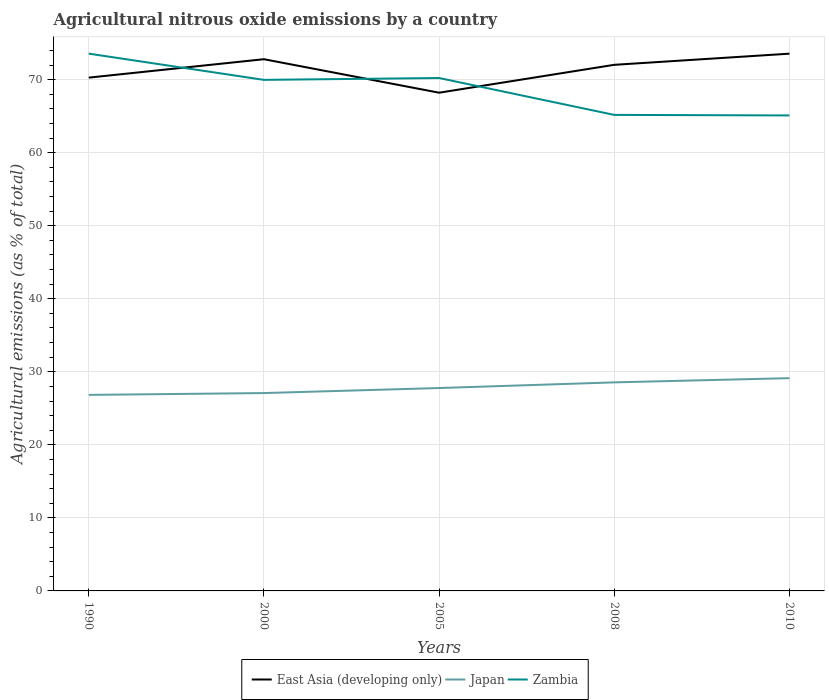Does the line corresponding to East Asia (developing only) intersect with the line corresponding to Zambia?
Keep it short and to the point. Yes. Across all years, what is the maximum amount of agricultural nitrous oxide emitted in East Asia (developing only)?
Provide a succinct answer. 68.21. What is the total amount of agricultural nitrous oxide emitted in Japan in the graph?
Provide a short and direct response. -0.77. What is the difference between the highest and the second highest amount of agricultural nitrous oxide emitted in Zambia?
Offer a very short reply. 8.46. What is the difference between the highest and the lowest amount of agricultural nitrous oxide emitted in Zambia?
Offer a terse response. 3. Is the amount of agricultural nitrous oxide emitted in East Asia (developing only) strictly greater than the amount of agricultural nitrous oxide emitted in Japan over the years?
Give a very brief answer. No. How many lines are there?
Make the answer very short. 3. How many years are there in the graph?
Your answer should be very brief. 5. Are the values on the major ticks of Y-axis written in scientific E-notation?
Make the answer very short. No. Where does the legend appear in the graph?
Your response must be concise. Bottom center. How many legend labels are there?
Provide a short and direct response. 3. What is the title of the graph?
Provide a succinct answer. Agricultural nitrous oxide emissions by a country. What is the label or title of the X-axis?
Offer a very short reply. Years. What is the label or title of the Y-axis?
Give a very brief answer. Agricultural emissions (as % of total). What is the Agricultural emissions (as % of total) of East Asia (developing only) in 1990?
Your answer should be compact. 70.28. What is the Agricultural emissions (as % of total) of Japan in 1990?
Offer a very short reply. 26.84. What is the Agricultural emissions (as % of total) in Zambia in 1990?
Provide a succinct answer. 73.56. What is the Agricultural emissions (as % of total) of East Asia (developing only) in 2000?
Your answer should be very brief. 72.8. What is the Agricultural emissions (as % of total) of Japan in 2000?
Ensure brevity in your answer.  27.09. What is the Agricultural emissions (as % of total) in Zambia in 2000?
Make the answer very short. 69.97. What is the Agricultural emissions (as % of total) in East Asia (developing only) in 2005?
Keep it short and to the point. 68.21. What is the Agricultural emissions (as % of total) of Japan in 2005?
Make the answer very short. 27.78. What is the Agricultural emissions (as % of total) of Zambia in 2005?
Your answer should be very brief. 70.22. What is the Agricultural emissions (as % of total) in East Asia (developing only) in 2008?
Your answer should be compact. 72.03. What is the Agricultural emissions (as % of total) in Japan in 2008?
Provide a succinct answer. 28.55. What is the Agricultural emissions (as % of total) of Zambia in 2008?
Offer a terse response. 65.17. What is the Agricultural emissions (as % of total) in East Asia (developing only) in 2010?
Make the answer very short. 73.56. What is the Agricultural emissions (as % of total) of Japan in 2010?
Give a very brief answer. 29.13. What is the Agricultural emissions (as % of total) of Zambia in 2010?
Your response must be concise. 65.1. Across all years, what is the maximum Agricultural emissions (as % of total) in East Asia (developing only)?
Provide a short and direct response. 73.56. Across all years, what is the maximum Agricultural emissions (as % of total) in Japan?
Provide a succinct answer. 29.13. Across all years, what is the maximum Agricultural emissions (as % of total) of Zambia?
Ensure brevity in your answer.  73.56. Across all years, what is the minimum Agricultural emissions (as % of total) in East Asia (developing only)?
Your answer should be compact. 68.21. Across all years, what is the minimum Agricultural emissions (as % of total) in Japan?
Your answer should be compact. 26.84. Across all years, what is the minimum Agricultural emissions (as % of total) of Zambia?
Provide a short and direct response. 65.1. What is the total Agricultural emissions (as % of total) of East Asia (developing only) in the graph?
Give a very brief answer. 356.87. What is the total Agricultural emissions (as % of total) in Japan in the graph?
Provide a short and direct response. 139.39. What is the total Agricultural emissions (as % of total) of Zambia in the graph?
Keep it short and to the point. 344.03. What is the difference between the Agricultural emissions (as % of total) in East Asia (developing only) in 1990 and that in 2000?
Offer a terse response. -2.52. What is the difference between the Agricultural emissions (as % of total) in Japan in 1990 and that in 2000?
Make the answer very short. -0.25. What is the difference between the Agricultural emissions (as % of total) of Zambia in 1990 and that in 2000?
Give a very brief answer. 3.59. What is the difference between the Agricultural emissions (as % of total) in East Asia (developing only) in 1990 and that in 2005?
Provide a succinct answer. 2.07. What is the difference between the Agricultural emissions (as % of total) in Japan in 1990 and that in 2005?
Give a very brief answer. -0.94. What is the difference between the Agricultural emissions (as % of total) of Zambia in 1990 and that in 2005?
Give a very brief answer. 3.34. What is the difference between the Agricultural emissions (as % of total) in East Asia (developing only) in 1990 and that in 2008?
Your answer should be very brief. -1.75. What is the difference between the Agricultural emissions (as % of total) of Japan in 1990 and that in 2008?
Your answer should be very brief. -1.71. What is the difference between the Agricultural emissions (as % of total) of Zambia in 1990 and that in 2008?
Offer a very short reply. 8.39. What is the difference between the Agricultural emissions (as % of total) in East Asia (developing only) in 1990 and that in 2010?
Provide a succinct answer. -3.28. What is the difference between the Agricultural emissions (as % of total) of Japan in 1990 and that in 2010?
Provide a short and direct response. -2.29. What is the difference between the Agricultural emissions (as % of total) of Zambia in 1990 and that in 2010?
Give a very brief answer. 8.46. What is the difference between the Agricultural emissions (as % of total) of East Asia (developing only) in 2000 and that in 2005?
Provide a short and direct response. 4.59. What is the difference between the Agricultural emissions (as % of total) of Japan in 2000 and that in 2005?
Your answer should be very brief. -0.69. What is the difference between the Agricultural emissions (as % of total) in Zambia in 2000 and that in 2005?
Offer a very short reply. -0.25. What is the difference between the Agricultural emissions (as % of total) in East Asia (developing only) in 2000 and that in 2008?
Your answer should be compact. 0.77. What is the difference between the Agricultural emissions (as % of total) of Japan in 2000 and that in 2008?
Your answer should be very brief. -1.46. What is the difference between the Agricultural emissions (as % of total) in Zambia in 2000 and that in 2008?
Your answer should be compact. 4.8. What is the difference between the Agricultural emissions (as % of total) of East Asia (developing only) in 2000 and that in 2010?
Your answer should be very brief. -0.76. What is the difference between the Agricultural emissions (as % of total) in Japan in 2000 and that in 2010?
Provide a short and direct response. -2.04. What is the difference between the Agricultural emissions (as % of total) in Zambia in 2000 and that in 2010?
Your answer should be very brief. 4.87. What is the difference between the Agricultural emissions (as % of total) in East Asia (developing only) in 2005 and that in 2008?
Your response must be concise. -3.82. What is the difference between the Agricultural emissions (as % of total) of Japan in 2005 and that in 2008?
Give a very brief answer. -0.77. What is the difference between the Agricultural emissions (as % of total) of Zambia in 2005 and that in 2008?
Keep it short and to the point. 5.05. What is the difference between the Agricultural emissions (as % of total) in East Asia (developing only) in 2005 and that in 2010?
Your answer should be compact. -5.34. What is the difference between the Agricultural emissions (as % of total) of Japan in 2005 and that in 2010?
Your answer should be very brief. -1.35. What is the difference between the Agricultural emissions (as % of total) of Zambia in 2005 and that in 2010?
Make the answer very short. 5.12. What is the difference between the Agricultural emissions (as % of total) in East Asia (developing only) in 2008 and that in 2010?
Your response must be concise. -1.53. What is the difference between the Agricultural emissions (as % of total) in Japan in 2008 and that in 2010?
Ensure brevity in your answer.  -0.58. What is the difference between the Agricultural emissions (as % of total) of Zambia in 2008 and that in 2010?
Ensure brevity in your answer.  0.07. What is the difference between the Agricultural emissions (as % of total) in East Asia (developing only) in 1990 and the Agricultural emissions (as % of total) in Japan in 2000?
Offer a terse response. 43.19. What is the difference between the Agricultural emissions (as % of total) in East Asia (developing only) in 1990 and the Agricultural emissions (as % of total) in Zambia in 2000?
Provide a succinct answer. 0.31. What is the difference between the Agricultural emissions (as % of total) in Japan in 1990 and the Agricultural emissions (as % of total) in Zambia in 2000?
Offer a terse response. -43.13. What is the difference between the Agricultural emissions (as % of total) in East Asia (developing only) in 1990 and the Agricultural emissions (as % of total) in Japan in 2005?
Keep it short and to the point. 42.5. What is the difference between the Agricultural emissions (as % of total) in East Asia (developing only) in 1990 and the Agricultural emissions (as % of total) in Zambia in 2005?
Your answer should be very brief. 0.05. What is the difference between the Agricultural emissions (as % of total) of Japan in 1990 and the Agricultural emissions (as % of total) of Zambia in 2005?
Offer a terse response. -43.38. What is the difference between the Agricultural emissions (as % of total) in East Asia (developing only) in 1990 and the Agricultural emissions (as % of total) in Japan in 2008?
Offer a very short reply. 41.73. What is the difference between the Agricultural emissions (as % of total) in East Asia (developing only) in 1990 and the Agricultural emissions (as % of total) in Zambia in 2008?
Offer a terse response. 5.1. What is the difference between the Agricultural emissions (as % of total) of Japan in 1990 and the Agricultural emissions (as % of total) of Zambia in 2008?
Offer a very short reply. -38.34. What is the difference between the Agricultural emissions (as % of total) of East Asia (developing only) in 1990 and the Agricultural emissions (as % of total) of Japan in 2010?
Provide a short and direct response. 41.15. What is the difference between the Agricultural emissions (as % of total) in East Asia (developing only) in 1990 and the Agricultural emissions (as % of total) in Zambia in 2010?
Keep it short and to the point. 5.18. What is the difference between the Agricultural emissions (as % of total) in Japan in 1990 and the Agricultural emissions (as % of total) in Zambia in 2010?
Ensure brevity in your answer.  -38.26. What is the difference between the Agricultural emissions (as % of total) in East Asia (developing only) in 2000 and the Agricultural emissions (as % of total) in Japan in 2005?
Provide a short and direct response. 45.02. What is the difference between the Agricultural emissions (as % of total) of East Asia (developing only) in 2000 and the Agricultural emissions (as % of total) of Zambia in 2005?
Your response must be concise. 2.58. What is the difference between the Agricultural emissions (as % of total) in Japan in 2000 and the Agricultural emissions (as % of total) in Zambia in 2005?
Your answer should be very brief. -43.13. What is the difference between the Agricultural emissions (as % of total) of East Asia (developing only) in 2000 and the Agricultural emissions (as % of total) of Japan in 2008?
Provide a succinct answer. 44.25. What is the difference between the Agricultural emissions (as % of total) of East Asia (developing only) in 2000 and the Agricultural emissions (as % of total) of Zambia in 2008?
Your response must be concise. 7.62. What is the difference between the Agricultural emissions (as % of total) in Japan in 2000 and the Agricultural emissions (as % of total) in Zambia in 2008?
Your response must be concise. -38.09. What is the difference between the Agricultural emissions (as % of total) of East Asia (developing only) in 2000 and the Agricultural emissions (as % of total) of Japan in 2010?
Offer a terse response. 43.67. What is the difference between the Agricultural emissions (as % of total) of East Asia (developing only) in 2000 and the Agricultural emissions (as % of total) of Zambia in 2010?
Offer a very short reply. 7.7. What is the difference between the Agricultural emissions (as % of total) of Japan in 2000 and the Agricultural emissions (as % of total) of Zambia in 2010?
Provide a short and direct response. -38.01. What is the difference between the Agricultural emissions (as % of total) in East Asia (developing only) in 2005 and the Agricultural emissions (as % of total) in Japan in 2008?
Your answer should be very brief. 39.66. What is the difference between the Agricultural emissions (as % of total) of East Asia (developing only) in 2005 and the Agricultural emissions (as % of total) of Zambia in 2008?
Keep it short and to the point. 3.04. What is the difference between the Agricultural emissions (as % of total) in Japan in 2005 and the Agricultural emissions (as % of total) in Zambia in 2008?
Your answer should be very brief. -37.4. What is the difference between the Agricultural emissions (as % of total) in East Asia (developing only) in 2005 and the Agricultural emissions (as % of total) in Japan in 2010?
Give a very brief answer. 39.08. What is the difference between the Agricultural emissions (as % of total) of East Asia (developing only) in 2005 and the Agricultural emissions (as % of total) of Zambia in 2010?
Your response must be concise. 3.11. What is the difference between the Agricultural emissions (as % of total) in Japan in 2005 and the Agricultural emissions (as % of total) in Zambia in 2010?
Offer a very short reply. -37.32. What is the difference between the Agricultural emissions (as % of total) in East Asia (developing only) in 2008 and the Agricultural emissions (as % of total) in Japan in 2010?
Make the answer very short. 42.9. What is the difference between the Agricultural emissions (as % of total) in East Asia (developing only) in 2008 and the Agricultural emissions (as % of total) in Zambia in 2010?
Your answer should be very brief. 6.93. What is the difference between the Agricultural emissions (as % of total) in Japan in 2008 and the Agricultural emissions (as % of total) in Zambia in 2010?
Offer a terse response. -36.55. What is the average Agricultural emissions (as % of total) of East Asia (developing only) per year?
Make the answer very short. 71.37. What is the average Agricultural emissions (as % of total) in Japan per year?
Offer a terse response. 27.88. What is the average Agricultural emissions (as % of total) in Zambia per year?
Provide a succinct answer. 68.81. In the year 1990, what is the difference between the Agricultural emissions (as % of total) in East Asia (developing only) and Agricultural emissions (as % of total) in Japan?
Offer a very short reply. 43.44. In the year 1990, what is the difference between the Agricultural emissions (as % of total) of East Asia (developing only) and Agricultural emissions (as % of total) of Zambia?
Your response must be concise. -3.28. In the year 1990, what is the difference between the Agricultural emissions (as % of total) in Japan and Agricultural emissions (as % of total) in Zambia?
Provide a short and direct response. -46.72. In the year 2000, what is the difference between the Agricultural emissions (as % of total) of East Asia (developing only) and Agricultural emissions (as % of total) of Japan?
Ensure brevity in your answer.  45.71. In the year 2000, what is the difference between the Agricultural emissions (as % of total) in East Asia (developing only) and Agricultural emissions (as % of total) in Zambia?
Offer a very short reply. 2.83. In the year 2000, what is the difference between the Agricultural emissions (as % of total) of Japan and Agricultural emissions (as % of total) of Zambia?
Your answer should be compact. -42.88. In the year 2005, what is the difference between the Agricultural emissions (as % of total) of East Asia (developing only) and Agricultural emissions (as % of total) of Japan?
Provide a short and direct response. 40.43. In the year 2005, what is the difference between the Agricultural emissions (as % of total) of East Asia (developing only) and Agricultural emissions (as % of total) of Zambia?
Your answer should be very brief. -2.01. In the year 2005, what is the difference between the Agricultural emissions (as % of total) in Japan and Agricultural emissions (as % of total) in Zambia?
Provide a short and direct response. -42.44. In the year 2008, what is the difference between the Agricultural emissions (as % of total) of East Asia (developing only) and Agricultural emissions (as % of total) of Japan?
Offer a very short reply. 43.48. In the year 2008, what is the difference between the Agricultural emissions (as % of total) of East Asia (developing only) and Agricultural emissions (as % of total) of Zambia?
Your answer should be very brief. 6.86. In the year 2008, what is the difference between the Agricultural emissions (as % of total) of Japan and Agricultural emissions (as % of total) of Zambia?
Ensure brevity in your answer.  -36.62. In the year 2010, what is the difference between the Agricultural emissions (as % of total) in East Asia (developing only) and Agricultural emissions (as % of total) in Japan?
Keep it short and to the point. 44.43. In the year 2010, what is the difference between the Agricultural emissions (as % of total) in East Asia (developing only) and Agricultural emissions (as % of total) in Zambia?
Offer a terse response. 8.46. In the year 2010, what is the difference between the Agricultural emissions (as % of total) in Japan and Agricultural emissions (as % of total) in Zambia?
Provide a succinct answer. -35.97. What is the ratio of the Agricultural emissions (as % of total) in East Asia (developing only) in 1990 to that in 2000?
Provide a succinct answer. 0.97. What is the ratio of the Agricultural emissions (as % of total) of Zambia in 1990 to that in 2000?
Ensure brevity in your answer.  1.05. What is the ratio of the Agricultural emissions (as % of total) in East Asia (developing only) in 1990 to that in 2005?
Keep it short and to the point. 1.03. What is the ratio of the Agricultural emissions (as % of total) in Japan in 1990 to that in 2005?
Your answer should be very brief. 0.97. What is the ratio of the Agricultural emissions (as % of total) in Zambia in 1990 to that in 2005?
Ensure brevity in your answer.  1.05. What is the ratio of the Agricultural emissions (as % of total) in East Asia (developing only) in 1990 to that in 2008?
Give a very brief answer. 0.98. What is the ratio of the Agricultural emissions (as % of total) of Japan in 1990 to that in 2008?
Keep it short and to the point. 0.94. What is the ratio of the Agricultural emissions (as % of total) of Zambia in 1990 to that in 2008?
Provide a short and direct response. 1.13. What is the ratio of the Agricultural emissions (as % of total) of East Asia (developing only) in 1990 to that in 2010?
Your response must be concise. 0.96. What is the ratio of the Agricultural emissions (as % of total) of Japan in 1990 to that in 2010?
Your answer should be compact. 0.92. What is the ratio of the Agricultural emissions (as % of total) of Zambia in 1990 to that in 2010?
Your answer should be compact. 1.13. What is the ratio of the Agricultural emissions (as % of total) in East Asia (developing only) in 2000 to that in 2005?
Make the answer very short. 1.07. What is the ratio of the Agricultural emissions (as % of total) in Japan in 2000 to that in 2005?
Give a very brief answer. 0.98. What is the ratio of the Agricultural emissions (as % of total) of Zambia in 2000 to that in 2005?
Offer a very short reply. 1. What is the ratio of the Agricultural emissions (as % of total) of East Asia (developing only) in 2000 to that in 2008?
Offer a terse response. 1.01. What is the ratio of the Agricultural emissions (as % of total) of Japan in 2000 to that in 2008?
Your answer should be compact. 0.95. What is the ratio of the Agricultural emissions (as % of total) of Zambia in 2000 to that in 2008?
Your response must be concise. 1.07. What is the ratio of the Agricultural emissions (as % of total) of East Asia (developing only) in 2000 to that in 2010?
Provide a short and direct response. 0.99. What is the ratio of the Agricultural emissions (as % of total) of Japan in 2000 to that in 2010?
Your answer should be very brief. 0.93. What is the ratio of the Agricultural emissions (as % of total) in Zambia in 2000 to that in 2010?
Provide a short and direct response. 1.07. What is the ratio of the Agricultural emissions (as % of total) in East Asia (developing only) in 2005 to that in 2008?
Make the answer very short. 0.95. What is the ratio of the Agricultural emissions (as % of total) of Japan in 2005 to that in 2008?
Your response must be concise. 0.97. What is the ratio of the Agricultural emissions (as % of total) in Zambia in 2005 to that in 2008?
Give a very brief answer. 1.08. What is the ratio of the Agricultural emissions (as % of total) in East Asia (developing only) in 2005 to that in 2010?
Provide a succinct answer. 0.93. What is the ratio of the Agricultural emissions (as % of total) in Japan in 2005 to that in 2010?
Your response must be concise. 0.95. What is the ratio of the Agricultural emissions (as % of total) in Zambia in 2005 to that in 2010?
Provide a short and direct response. 1.08. What is the ratio of the Agricultural emissions (as % of total) of East Asia (developing only) in 2008 to that in 2010?
Keep it short and to the point. 0.98. What is the ratio of the Agricultural emissions (as % of total) of Japan in 2008 to that in 2010?
Provide a succinct answer. 0.98. What is the ratio of the Agricultural emissions (as % of total) in Zambia in 2008 to that in 2010?
Keep it short and to the point. 1. What is the difference between the highest and the second highest Agricultural emissions (as % of total) in East Asia (developing only)?
Give a very brief answer. 0.76. What is the difference between the highest and the second highest Agricultural emissions (as % of total) in Japan?
Offer a very short reply. 0.58. What is the difference between the highest and the second highest Agricultural emissions (as % of total) in Zambia?
Your response must be concise. 3.34. What is the difference between the highest and the lowest Agricultural emissions (as % of total) of East Asia (developing only)?
Provide a succinct answer. 5.34. What is the difference between the highest and the lowest Agricultural emissions (as % of total) of Japan?
Keep it short and to the point. 2.29. What is the difference between the highest and the lowest Agricultural emissions (as % of total) of Zambia?
Provide a succinct answer. 8.46. 